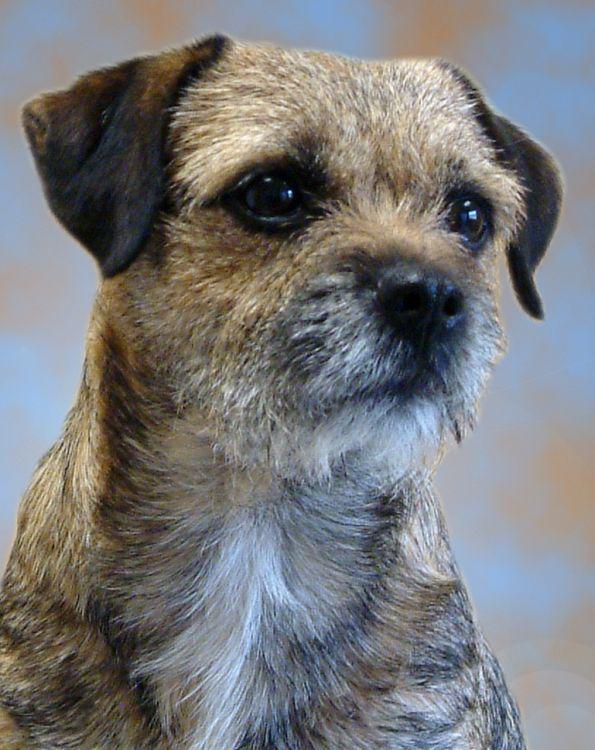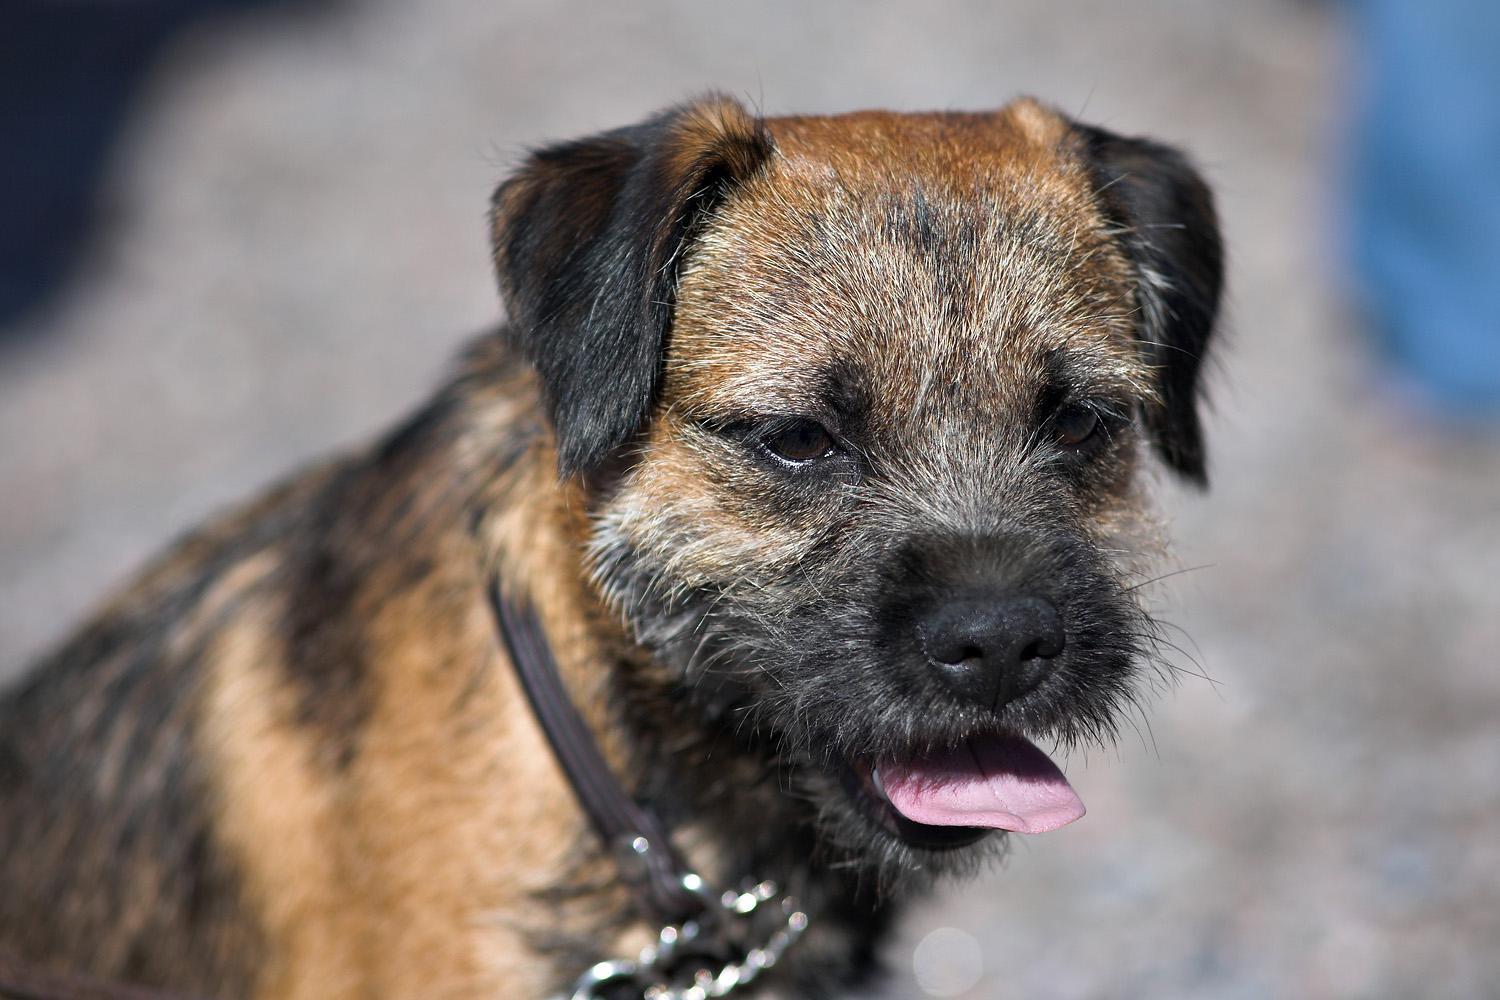The first image is the image on the left, the second image is the image on the right. Considering the images on both sides, is "One of the dogs is facing directly toward the left." valid? Answer yes or no. No. 